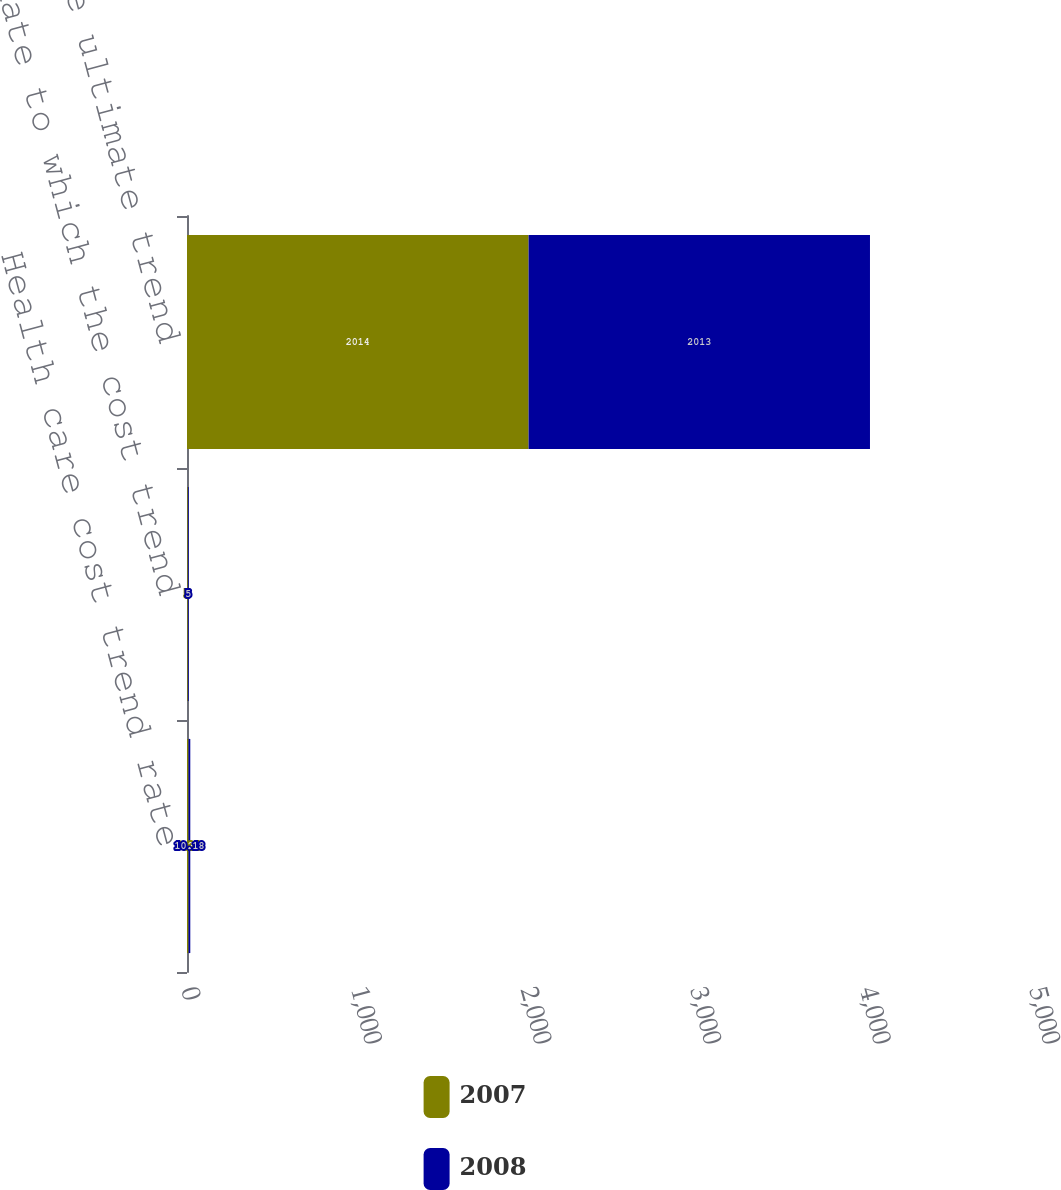Convert chart. <chart><loc_0><loc_0><loc_500><loc_500><stacked_bar_chart><ecel><fcel>Health care cost trend rate<fcel>Rate to which the cost trend<fcel>Fiscal year the ultimate trend<nl><fcel>2007<fcel>9.21<fcel>5<fcel>2014<nl><fcel>2008<fcel>10.18<fcel>5<fcel>2013<nl></chart> 